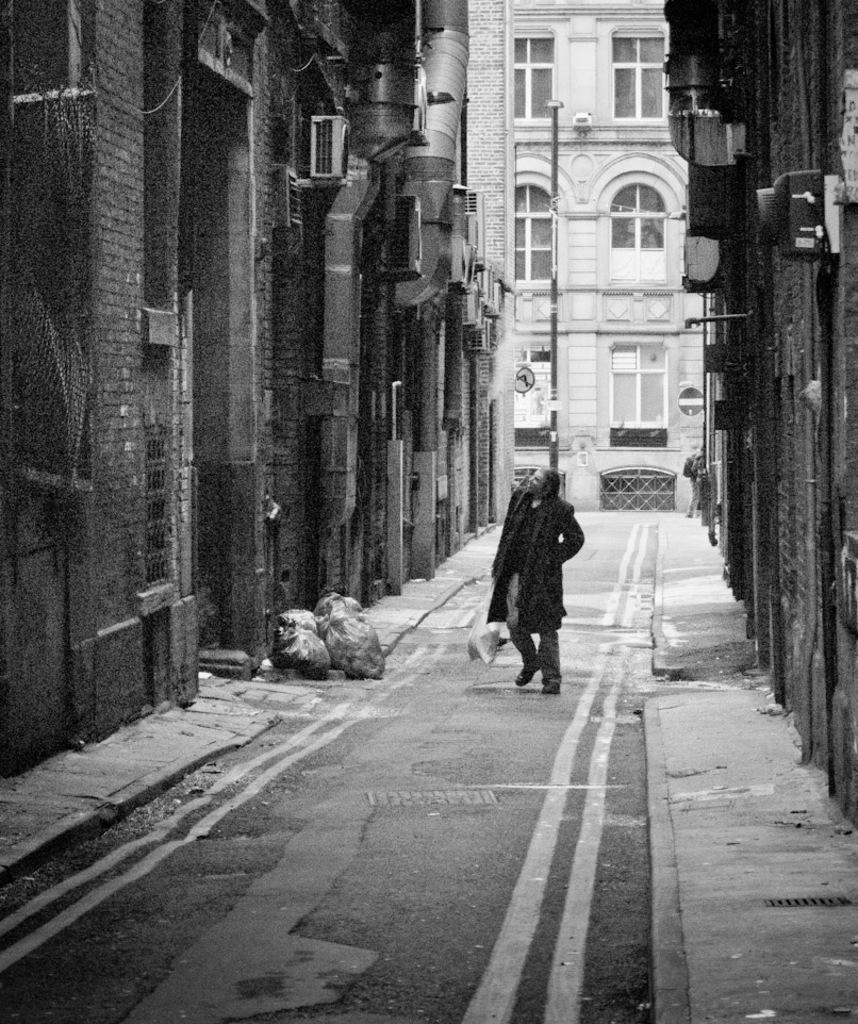What is the color scheme of the image? The image is black and white. What structures can be seen in the image? There are buildings and poles in the image. What object is present in the image that might be used for displaying information? There is a board in the image. What items are visible at the bottom of the image? There are bags at the bottom of the image. What is the person in the image doing? There is a person on the road holding a bag. How does the person in the image participate in the low competition? There is no mention of a low competition in the image, so it is not possible to answer this question. 